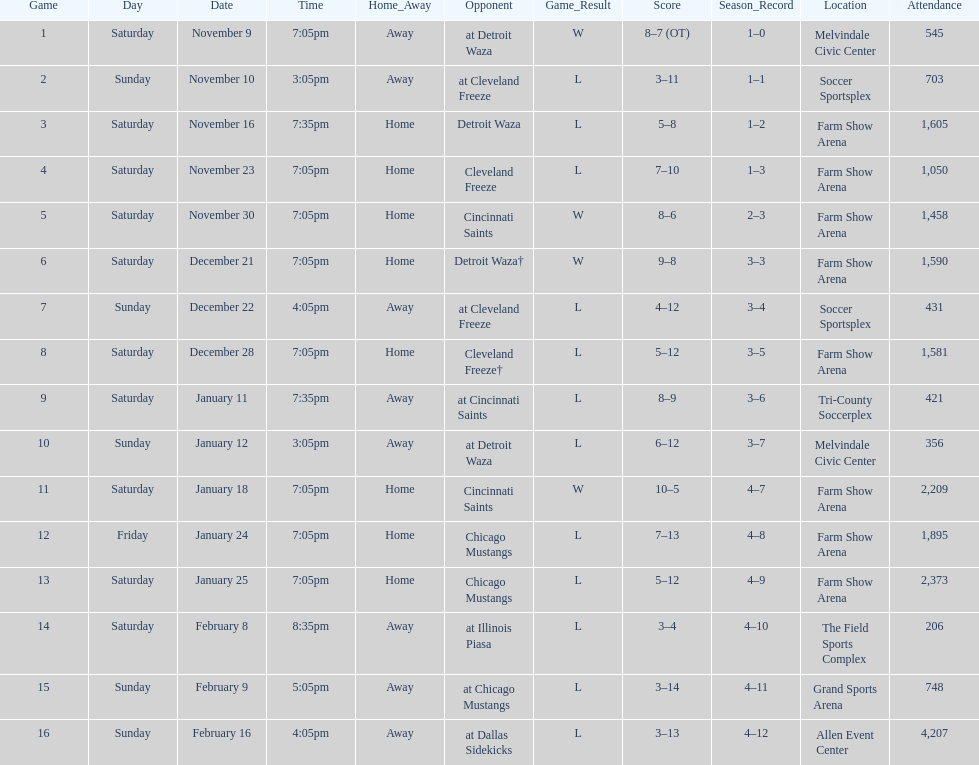What was the location before tri-county soccerplex? Farm Show Arena. 